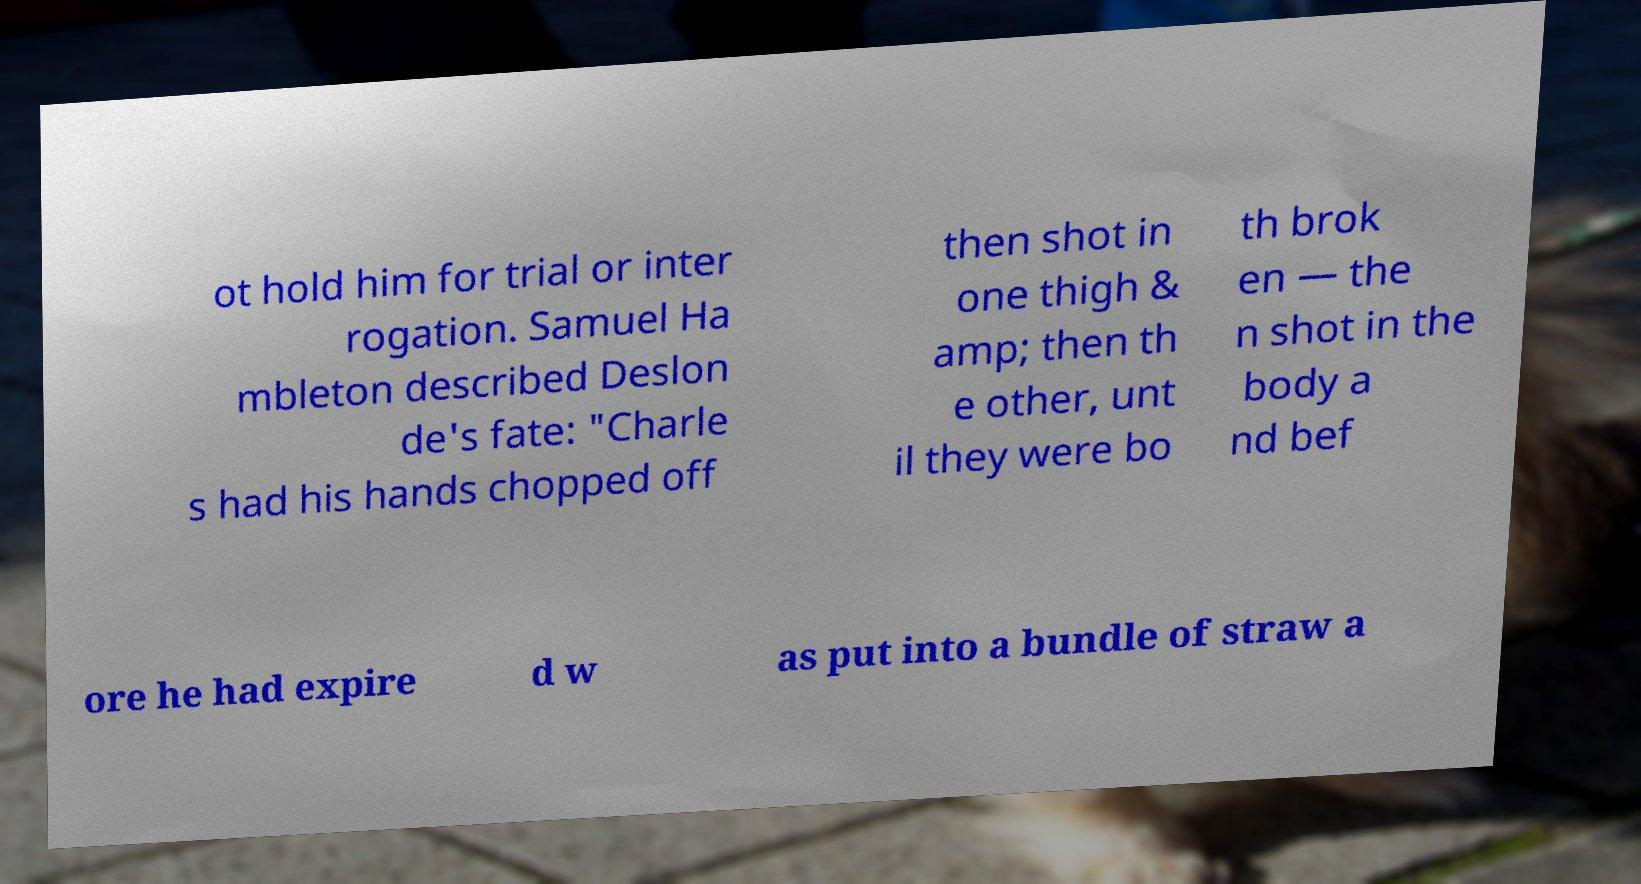Could you assist in decoding the text presented in this image and type it out clearly? ot hold him for trial or inter rogation. Samuel Ha mbleton described Deslon de's fate: "Charle s had his hands chopped off then shot in one thigh & amp; then th e other, unt il they were bo th brok en — the n shot in the body a nd bef ore he had expire d w as put into a bundle of straw a 